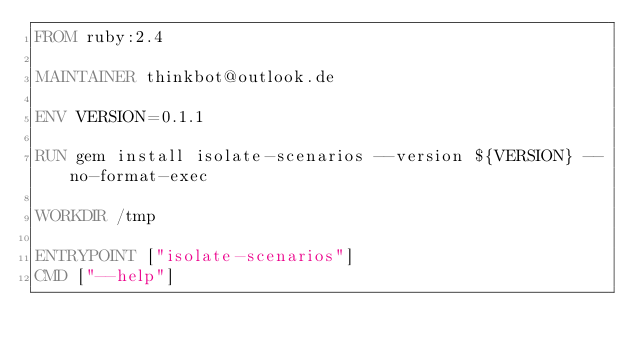Convert code to text. <code><loc_0><loc_0><loc_500><loc_500><_Dockerfile_>FROM ruby:2.4

MAINTAINER thinkbot@outlook.de

ENV VERSION=0.1.1

RUN gem install isolate-scenarios --version ${VERSION} --no-format-exec

WORKDIR /tmp

ENTRYPOINT ["isolate-scenarios"]
CMD ["--help"]
</code> 